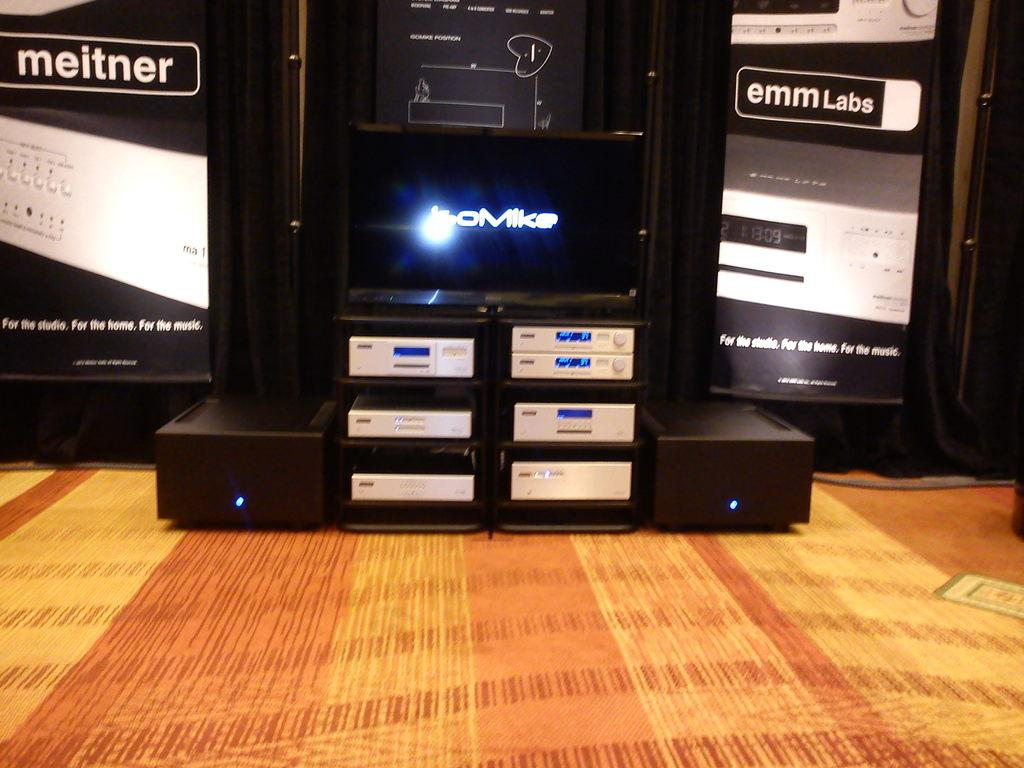<image>
Describe the image concisely. A box with the the brand name Meitner sits to the left of other black objects. 